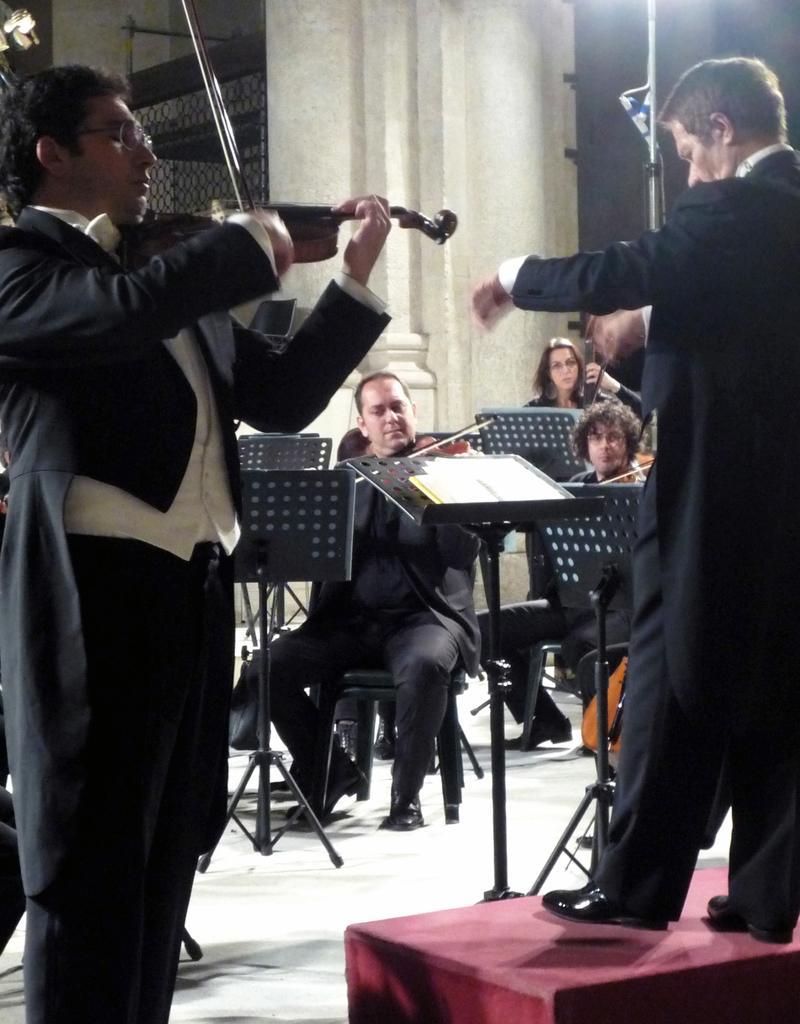In one or two sentences, can you explain what this image depicts? We can see three persons sitting on chairs and playing musical instruments. We can see two men standing here and playing a violin. 